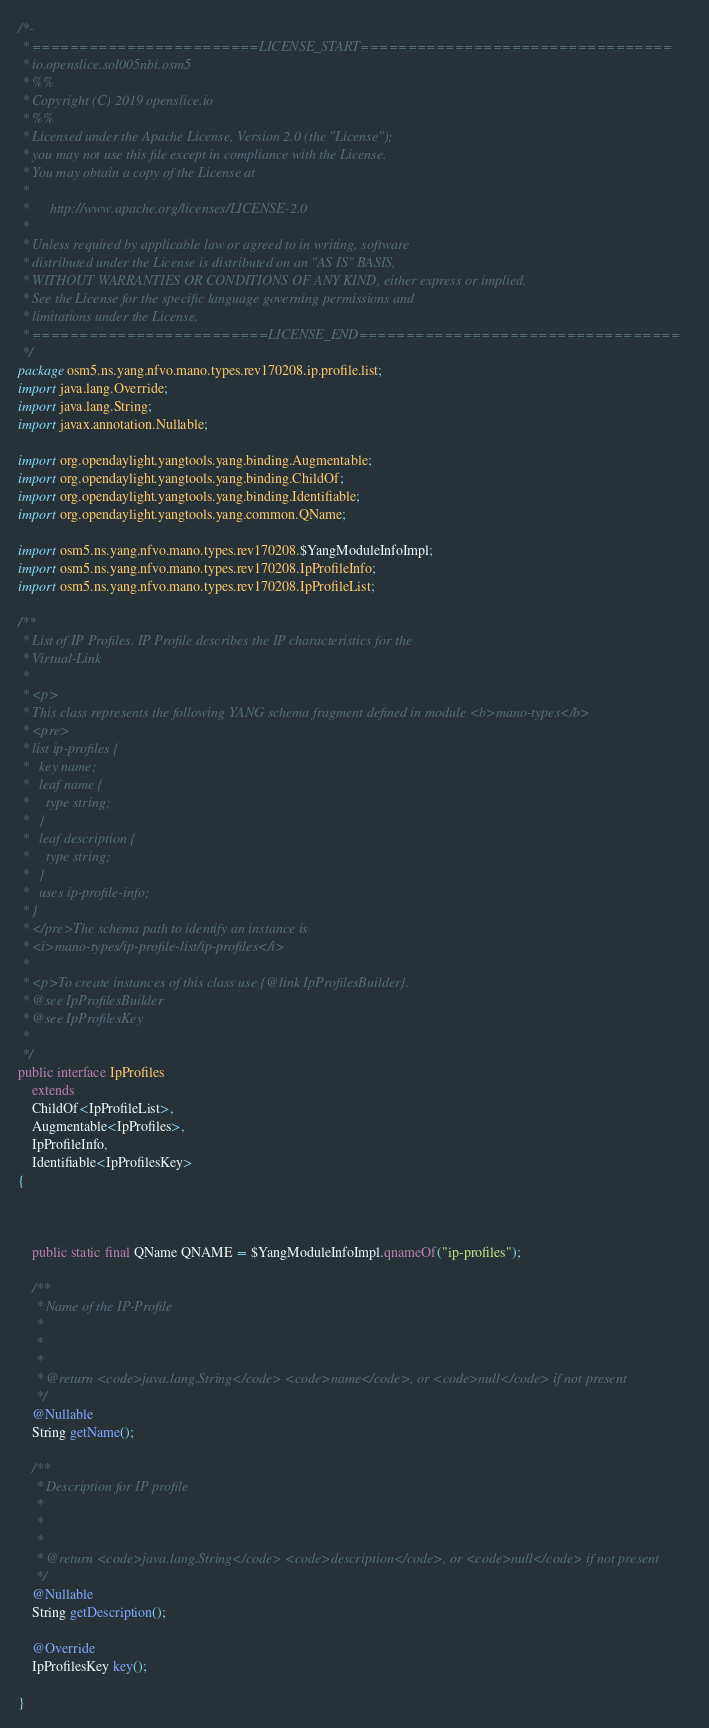Convert code to text. <code><loc_0><loc_0><loc_500><loc_500><_Java_>/*-
 * ========================LICENSE_START=================================
 * io.openslice.sol005nbi.osm5
 * %%
 * Copyright (C) 2019 openslice.io
 * %%
 * Licensed under the Apache License, Version 2.0 (the "License");
 * you may not use this file except in compliance with the License.
 * You may obtain a copy of the License at
 * 
 *      http://www.apache.org/licenses/LICENSE-2.0
 * 
 * Unless required by applicable law or agreed to in writing, software
 * distributed under the License is distributed on an "AS IS" BASIS,
 * WITHOUT WARRANTIES OR CONDITIONS OF ANY KIND, either express or implied.
 * See the License for the specific language governing permissions and
 * limitations under the License.
 * =========================LICENSE_END==================================
 */
package osm5.ns.yang.nfvo.mano.types.rev170208.ip.profile.list;
import java.lang.Override;
import java.lang.String;
import javax.annotation.Nullable;

import org.opendaylight.yangtools.yang.binding.Augmentable;
import org.opendaylight.yangtools.yang.binding.ChildOf;
import org.opendaylight.yangtools.yang.binding.Identifiable;
import org.opendaylight.yangtools.yang.common.QName;

import osm5.ns.yang.nfvo.mano.types.rev170208.$YangModuleInfoImpl;
import osm5.ns.yang.nfvo.mano.types.rev170208.IpProfileInfo;
import osm5.ns.yang.nfvo.mano.types.rev170208.IpProfileList;

/**
 * List of IP Profiles. IP Profile describes the IP characteristics for the 
 * Virtual-Link
 * 
 * <p>
 * This class represents the following YANG schema fragment defined in module <b>mano-types</b>
 * <pre>
 * list ip-profiles {
 *   key name;
 *   leaf name {
 *     type string;
 *   }
 *   leaf description {
 *     type string;
 *   }
 *   uses ip-profile-info;
 * }
 * </pre>The schema path to identify an instance is
 * <i>mano-types/ip-profile-list/ip-profiles</i>
 * 
 * <p>To create instances of this class use {@link IpProfilesBuilder}.
 * @see IpProfilesBuilder
 * @see IpProfilesKey
 *
 */
public interface IpProfiles
    extends
    ChildOf<IpProfileList>,
    Augmentable<IpProfiles>,
    IpProfileInfo,
    Identifiable<IpProfilesKey>
{



    public static final QName QNAME = $YangModuleInfoImpl.qnameOf("ip-profiles");

    /**
     * Name of the IP-Profile
     *
     *
     *
     * @return <code>java.lang.String</code> <code>name</code>, or <code>null</code> if not present
     */
    @Nullable
    String getName();
    
    /**
     * Description for IP profile
     *
     *
     *
     * @return <code>java.lang.String</code> <code>description</code>, or <code>null</code> if not present
     */
    @Nullable
    String getDescription();
    
    @Override
    IpProfilesKey key();

}

</code> 